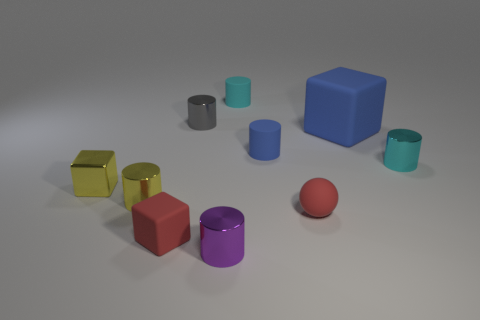What is the shape of the other blue thing that is the same material as the large blue object?
Your response must be concise. Cylinder. Are there any other things that are the same color as the large object?
Ensure brevity in your answer.  Yes. There is a shiny object on the right side of the tiny shiny thing that is in front of the small yellow metal cylinder; what number of purple shiny cylinders are to the right of it?
Make the answer very short. 0. What number of brown objects are large rubber cubes or shiny cylinders?
Offer a terse response. 0. Is the size of the gray metallic thing the same as the matte cube in front of the small cyan shiny object?
Your answer should be very brief. Yes. There is a small yellow object that is the same shape as the purple shiny thing; what is its material?
Offer a very short reply. Metal. How many other things are there of the same size as the yellow metal block?
Offer a terse response. 8. There is a gray object behind the small yellow metal object that is to the right of the yellow shiny thing to the left of the small yellow metal cylinder; what is its shape?
Provide a short and direct response. Cylinder. What shape is the rubber object that is both to the left of the tiny blue cylinder and in front of the blue rubber cylinder?
Provide a succinct answer. Cube. How many objects are either large red spheres or red rubber objects left of the small purple cylinder?
Keep it short and to the point. 1. 